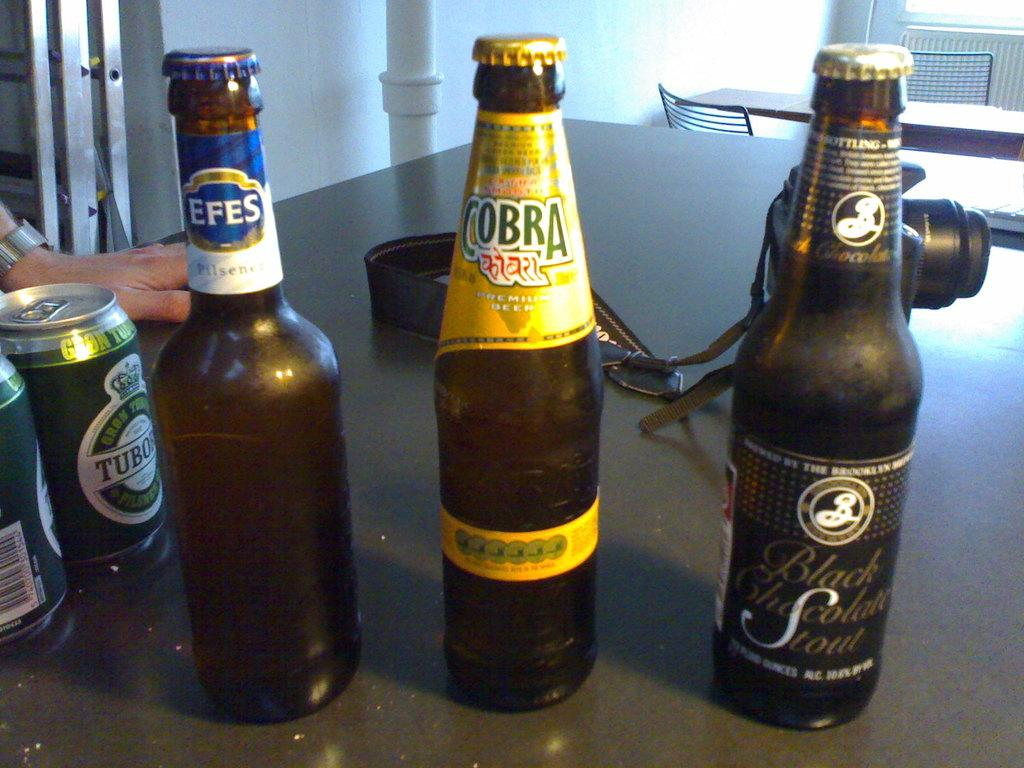<image>
Write a terse but informative summary of the picture. A bottle with cobra on the label is in between two others. 